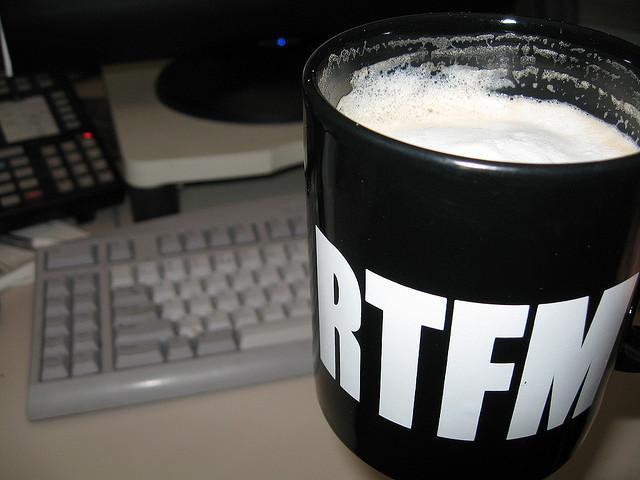How many color lights do you see?
Give a very brief answer. 2. 